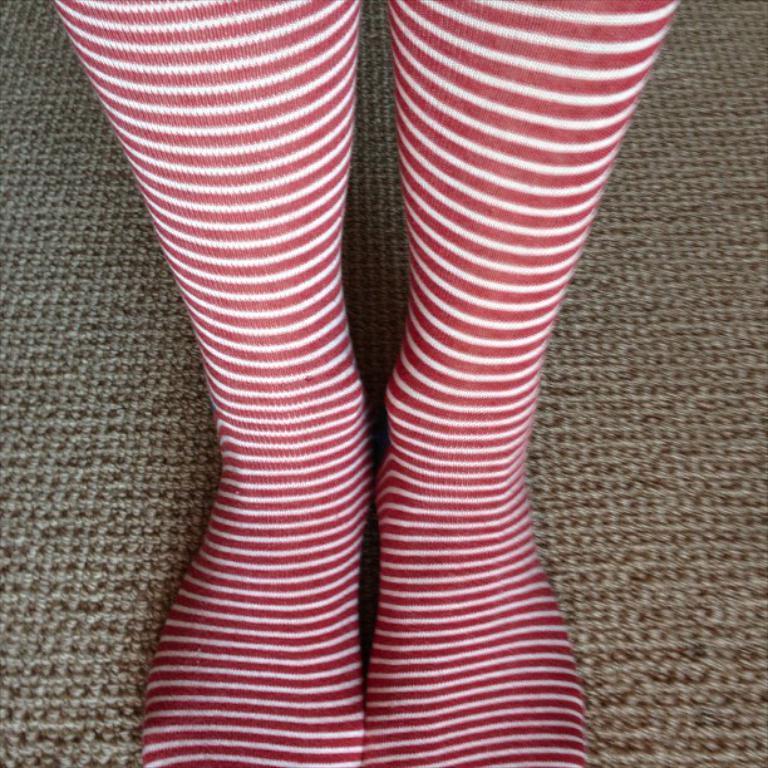How would you summarize this image in a sentence or two? In this image person's legs and a carpet. 